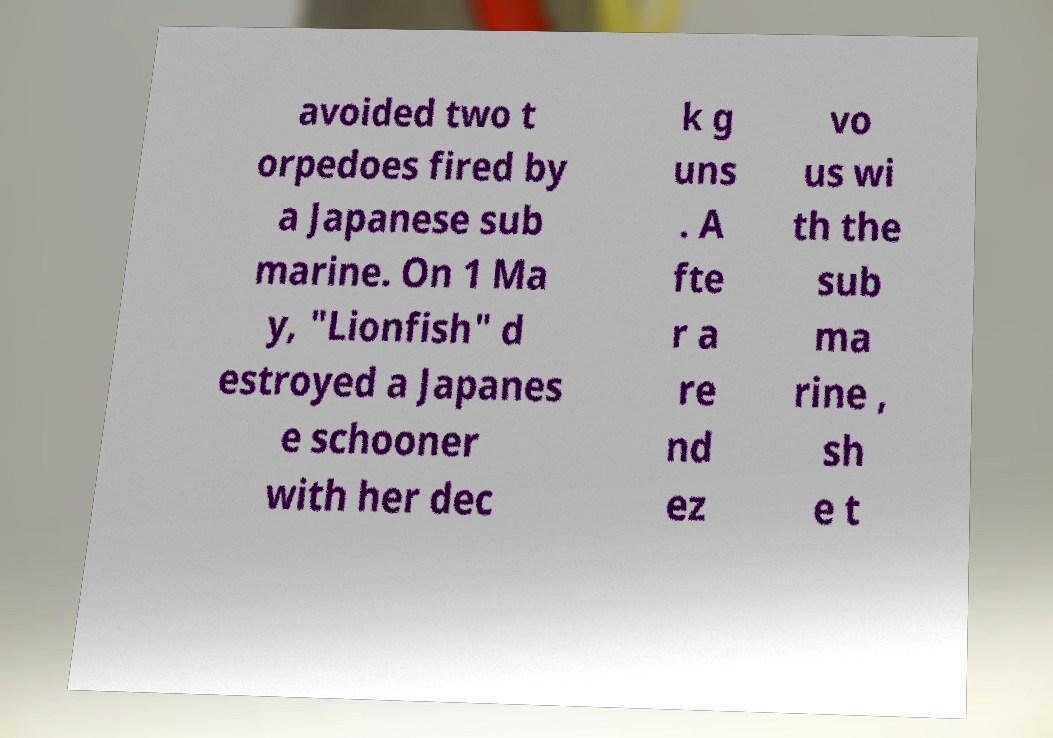Please identify and transcribe the text found in this image. avoided two t orpedoes fired by a Japanese sub marine. On 1 Ma y, "Lionfish" d estroyed a Japanes e schooner with her dec k g uns . A fte r a re nd ez vo us wi th the sub ma rine , sh e t 